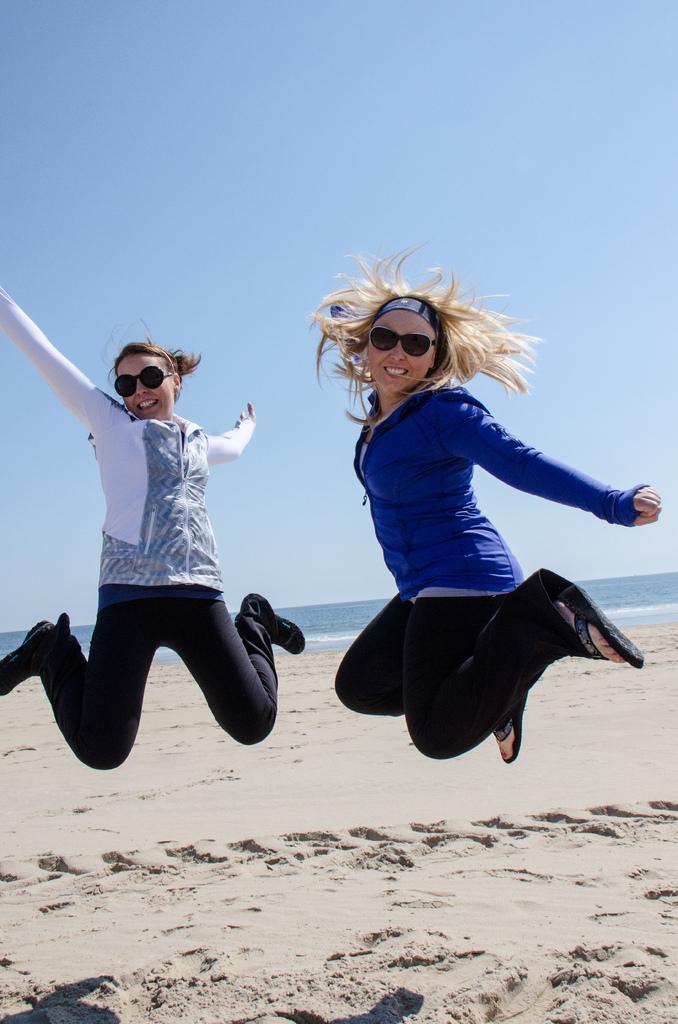Could you give a brief overview of what you see in this image? In this image in the center there are persons jumping and smiling and there is sand on the ground. In the background there is an ocean. 